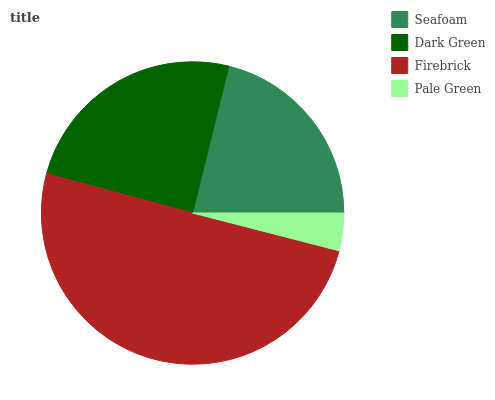Is Pale Green the minimum?
Answer yes or no. Yes. Is Firebrick the maximum?
Answer yes or no. Yes. Is Dark Green the minimum?
Answer yes or no. No. Is Dark Green the maximum?
Answer yes or no. No. Is Dark Green greater than Seafoam?
Answer yes or no. Yes. Is Seafoam less than Dark Green?
Answer yes or no. Yes. Is Seafoam greater than Dark Green?
Answer yes or no. No. Is Dark Green less than Seafoam?
Answer yes or no. No. Is Dark Green the high median?
Answer yes or no. Yes. Is Seafoam the low median?
Answer yes or no. Yes. Is Pale Green the high median?
Answer yes or no. No. Is Dark Green the low median?
Answer yes or no. No. 